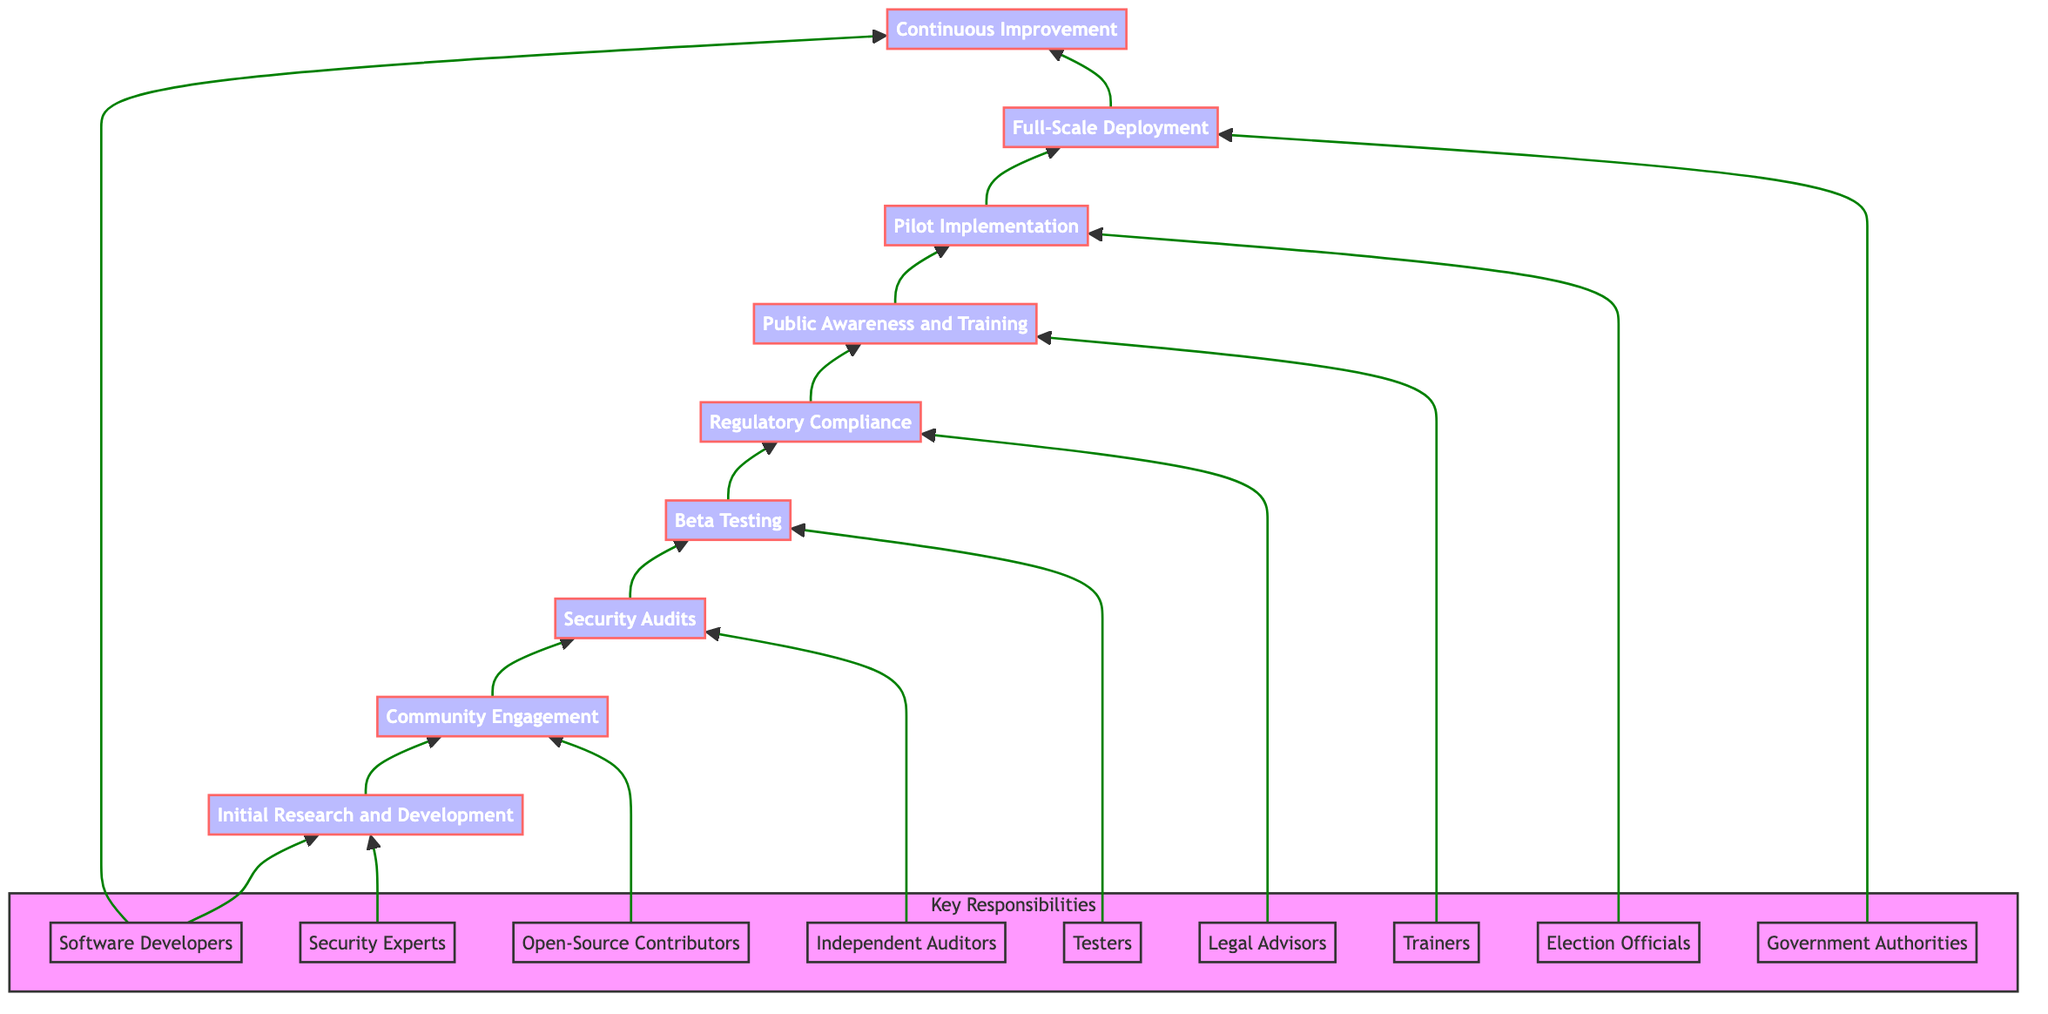What is the first step in the adoption pathway? The first step listed in the diagram is "Initial Research and Development," which is the starting point of the process outlined in the adoption pathway.
Answer: Initial Research and Development Who is responsible for the "Security Audits" step? The responsibilities listed for the "Security Audits" step are assigned to Independent Security Auditors, Penetration Testers, and Cryptographers, indicating that they play a crucial role in this part of the process.
Answer: Independent Security Auditors, Penetration Testers, Cryptographers How many total steps are there in the adoption pathway? By counting the distinct steps positioned from the bottom to the top in the diagram, there are nine individual steps that make up the entire adoption pathway.
Answer: Nine Which step comes after "Beta Testing"? The diagram shows that "Regulatory Compliance" follows after "Beta Testing," indicating the logical sequence in the pathway for adopting the software.
Answer: Regulatory Compliance What is the last step in the adoption pathway? The last step at the top of the diagram is "Continuous Improvement," which indicates ongoing efforts after the full deployment of the software.
Answer: Continuous Improvement What roles are involved in "Public Awareness and Training"? For the "Public Awareness and Training" step, the responsibilities include Trainers, Public Relations Teams, and Community Outreach Coordinators, highlighting diverse roles needed for this educational phase.
Answer: Trainers, Public Relations Teams, Community Outreach Coordinators Which two steps involve legal considerations? Both "Regulatory Compliance" and "Public Awareness and Training" involve legal considerations, with regulatory compliance ensuring adherence to laws and public awareness potentially covering legal aspects in training sessions.
Answer: Regulatory Compliance, Public Awareness and Training Which responsibility is connected to the "Full-Scale Deployment" step? The responsibilities related to the "Full-Scale Deployment" step are assigned to Election Commissions, Government Authorities, and IT Departments, reflecting the critical stakeholders for this deployment phase.
Answer: Election Commissions, Government Authorities, IT Departments What step precedes "Pilot Implementation"? According to the diagram, "Public Awareness and Training" is the step that comes just before "Pilot Implementation," emphasizing the importance of user education before a trial run.
Answer: Public Awareness and Training 